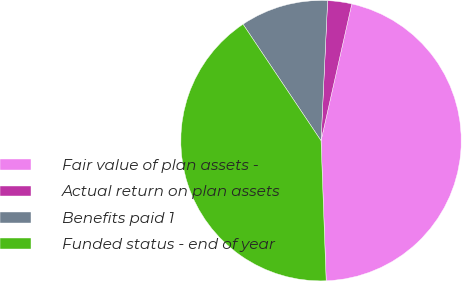<chart> <loc_0><loc_0><loc_500><loc_500><pie_chart><fcel>Fair value of plan assets -<fcel>Actual return on plan assets<fcel>Benefits paid 1<fcel>Funded status - end of year<nl><fcel>45.9%<fcel>2.77%<fcel>10.14%<fcel>41.19%<nl></chart> 